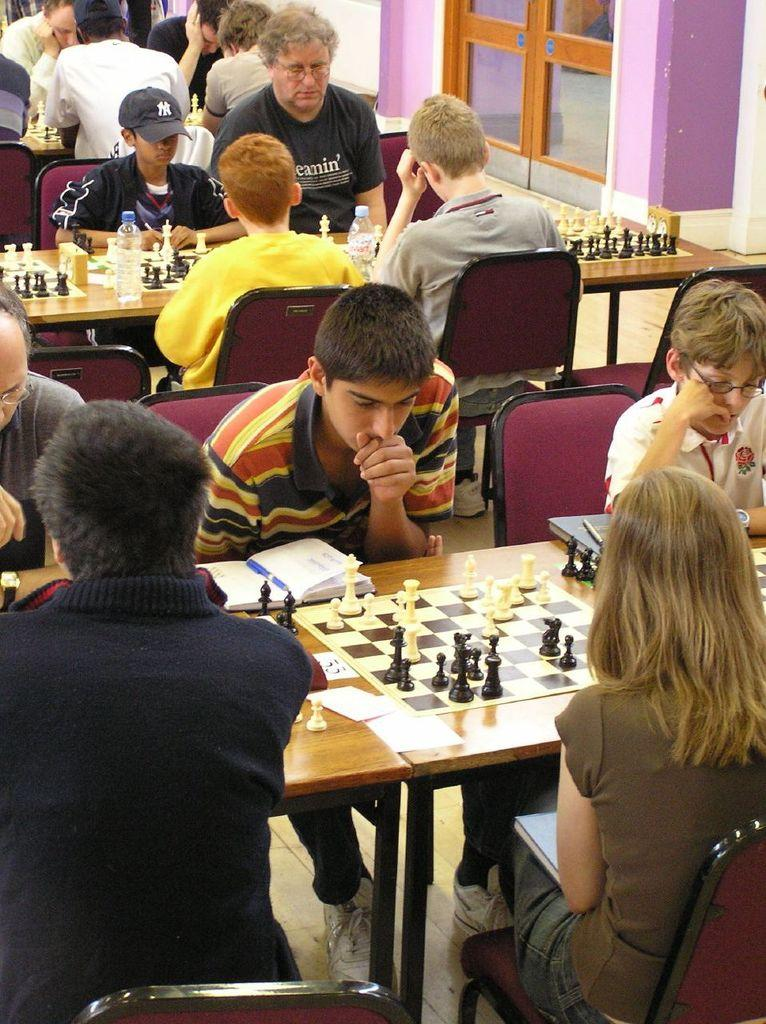What are the people in the image doing? The people in the image are sitting on chairs. What is on the table in the image? There are chess boards, bottles, and a book on the table. Can you describe the table in the image? The table has chess boards, bottles, and a book on it. What part of the room can be seen in the image? The floor is visible in the image. What type of cheese is being served on the table in the image? There is no cheese present on the table in the image. How many doors can be seen in the image? There are no doors visible in the image. 